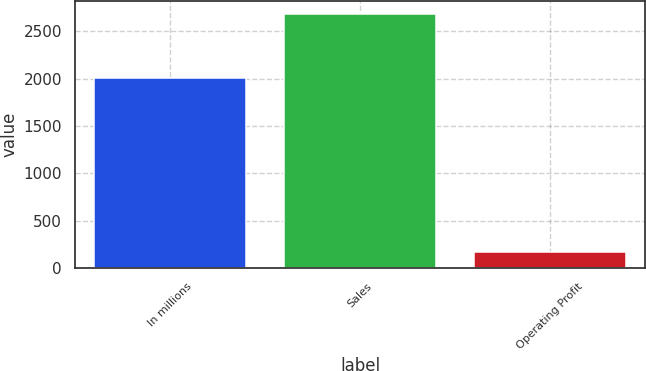<chart> <loc_0><loc_0><loc_500><loc_500><bar_chart><fcel>In millions<fcel>Sales<fcel>Operating Profit<nl><fcel>2006<fcel>2685<fcel>172<nl></chart> 